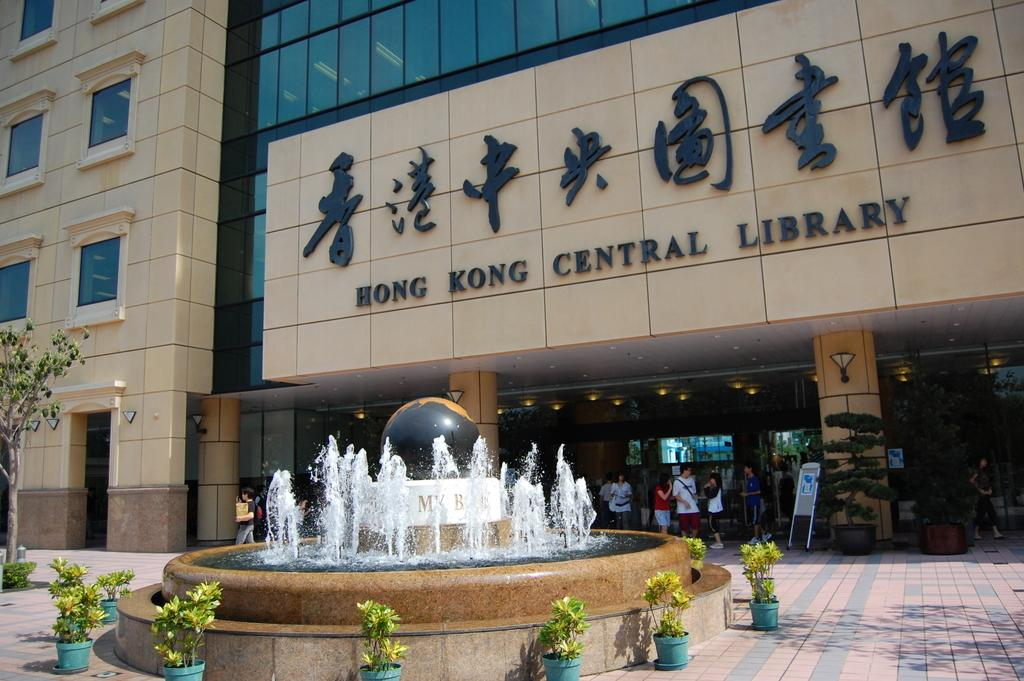<image>
Render a clear and concise summary of the photo. A fountain encircled by potted plants sits in front of the Hong Kong Central Library. 